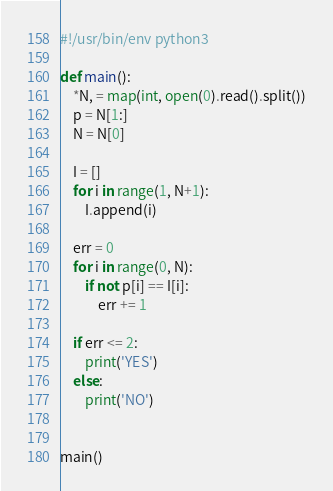Convert code to text. <code><loc_0><loc_0><loc_500><loc_500><_Python_>#!/usr/bin/env python3

def main():
    *N, = map(int, open(0).read().split())
    p = N[1:]
    N = N[0]

    I = []
    for i in range(1, N+1):
        I.append(i)
    
    err = 0
    for i in range(0, N):
        if not p[i] == I[i]:
            err += 1

    if err <= 2:
        print('YES')
    else:
        print('NO')


main()</code> 